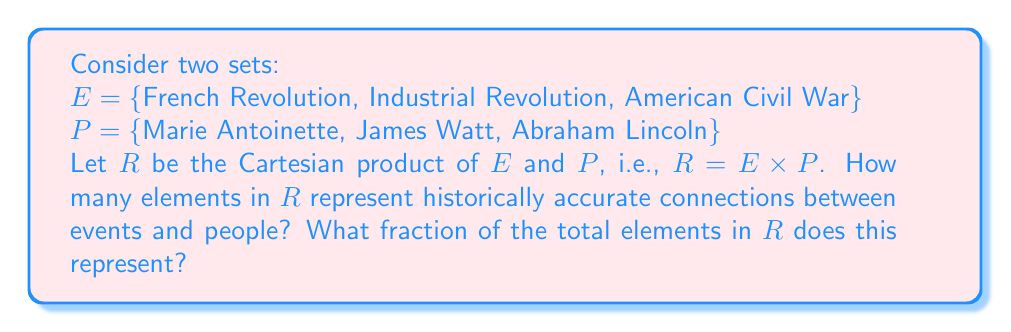Solve this math problem. To solve this problem, we need to follow these steps:

1) First, let's calculate the total number of elements in the Cartesian product $R = E \times P$:
   $|R| = |E| \times |P| = 3 \times 3 = 9$

2) Now, let's identify the historically accurate connections:
   - Marie Antoinette is associated with the French Revolution
   - James Watt is associated with the Industrial Revolution
   - Abraham Lincoln is associated with the American Civil War

3) Therefore, there are 3 historically accurate connections in $R$.

4) To calculate the fraction, we use:
   $$\frac{\text{number of accurate connections}}{\text{total number of elements in } R} = \frac{3}{9} = \frac{1}{3}$$

This fraction can be interpreted as follows: one-third of the possible connections in the Cartesian product represent historically accurate relationships between the events and people.

It's important to note that while these connections are historically accurate, they don't fully define these individuals or events. For instance, Marie Antoinette's life extended beyond just the French Revolution, James Watt made contributions outside the Industrial Revolution, and Abraham Lincoln's significance isn't limited to the American Civil War.
Answer: 3 elements in $R$ represent historically accurate connections, which is $\frac{1}{3}$ of the total elements in $R$. 